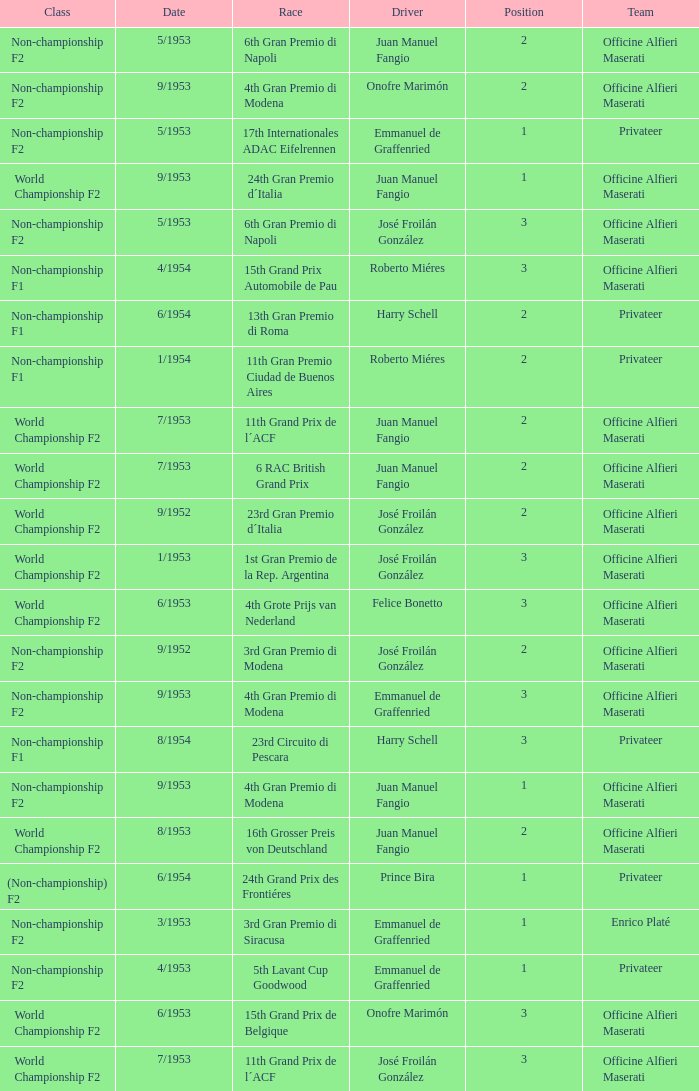What team has a drive name emmanuel de graffenried and a position larger than 1 as well as the date of 9/1953? Officine Alfieri Maserati. 